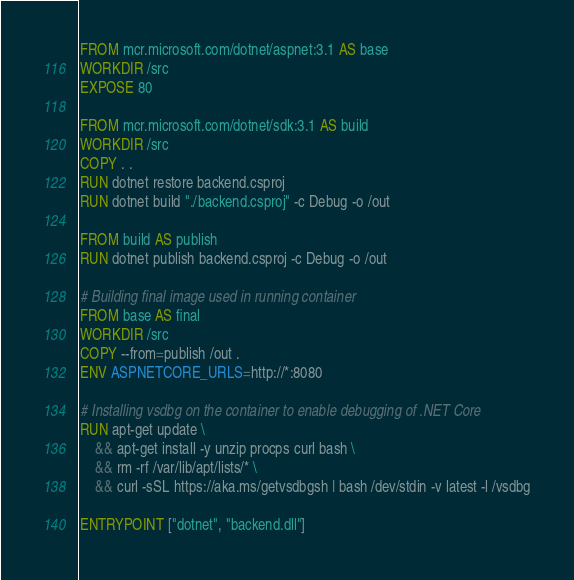<code> <loc_0><loc_0><loc_500><loc_500><_Dockerfile_>FROM mcr.microsoft.com/dotnet/aspnet:3.1 AS base
WORKDIR /src
EXPOSE 80

FROM mcr.microsoft.com/dotnet/sdk:3.1 AS build
WORKDIR /src
COPY . .
RUN dotnet restore backend.csproj
RUN dotnet build "./backend.csproj" -c Debug -o /out

FROM build AS publish
RUN dotnet publish backend.csproj -c Debug -o /out

# Building final image used in running container
FROM base AS final
WORKDIR /src
COPY --from=publish /out .
ENV ASPNETCORE_URLS=http://*:8080

# Installing vsdbg on the container to enable debugging of .NET Core
RUN apt-get update \
    && apt-get install -y unzip procps curl bash \
    && rm -rf /var/lib/apt/lists/* \
    && curl -sSL https://aka.ms/getvsdbgsh | bash /dev/stdin -v latest -l /vsdbg

ENTRYPOINT ["dotnet", "backend.dll"]
</code> 